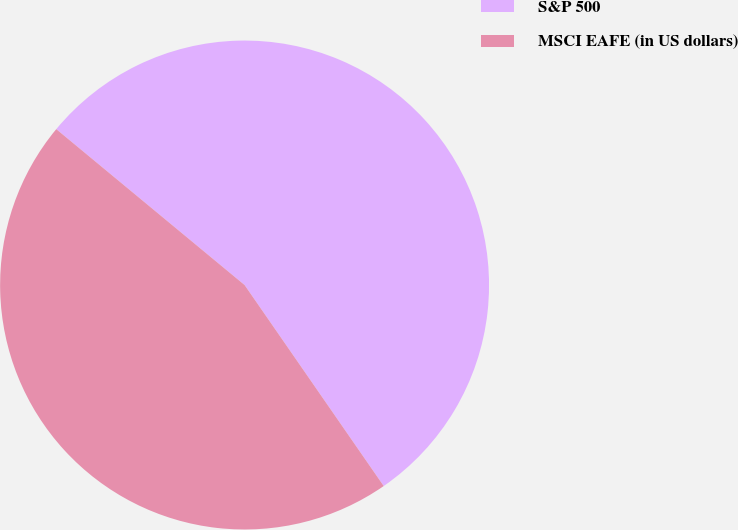Convert chart. <chart><loc_0><loc_0><loc_500><loc_500><pie_chart><fcel>S&P 500<fcel>MSCI EAFE (in US dollars)<nl><fcel>54.36%<fcel>45.64%<nl></chart> 